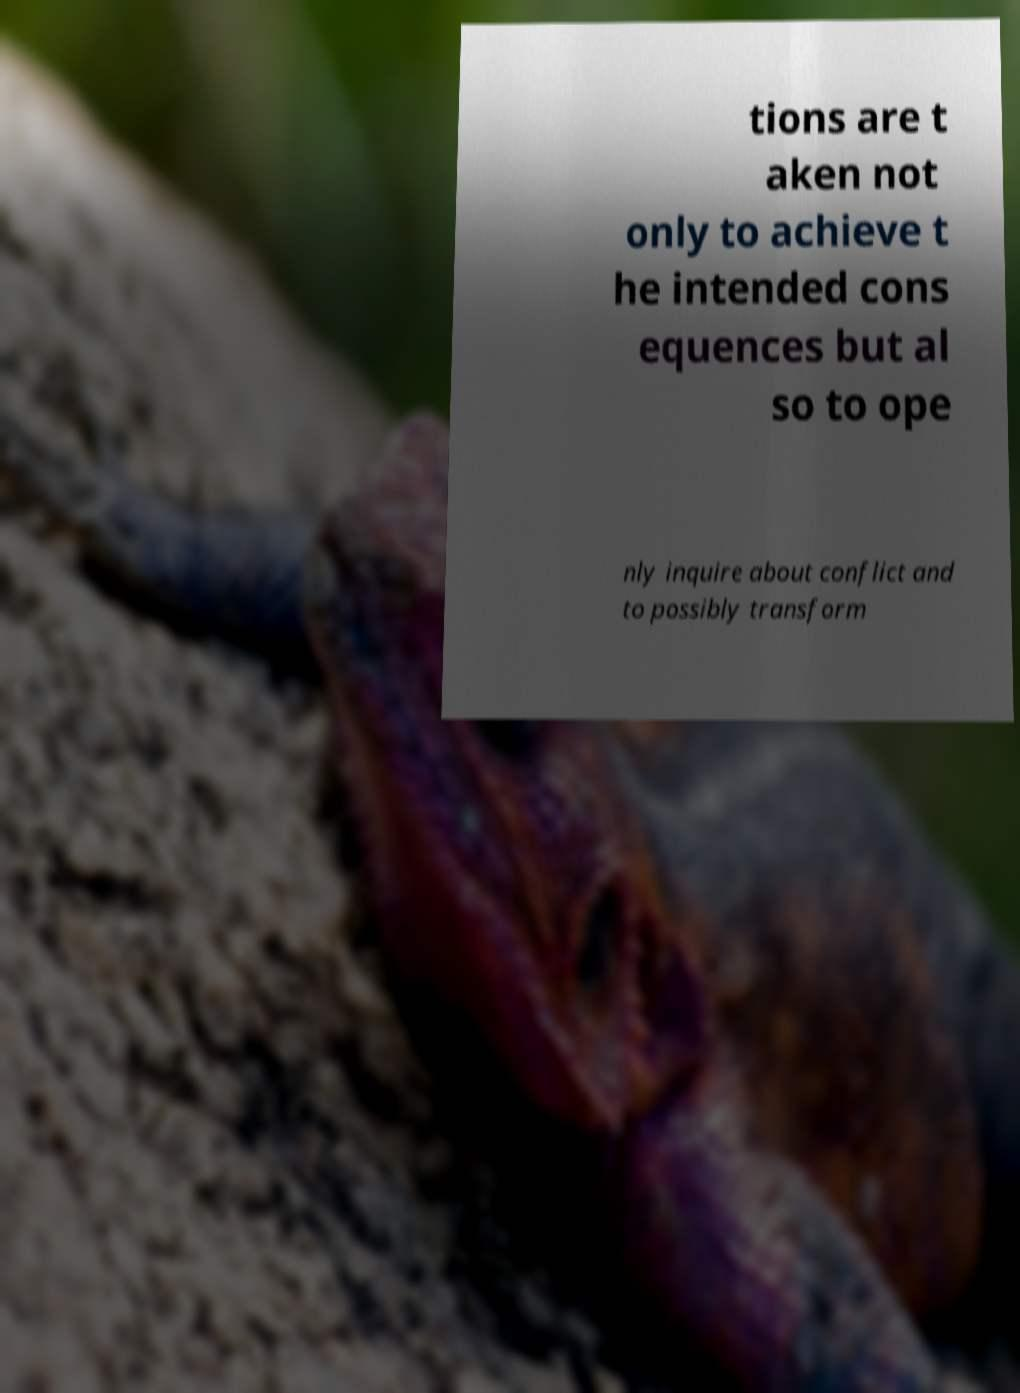Can you read and provide the text displayed in the image?This photo seems to have some interesting text. Can you extract and type it out for me? tions are t aken not only to achieve t he intended cons equences but al so to ope nly inquire about conflict and to possibly transform 